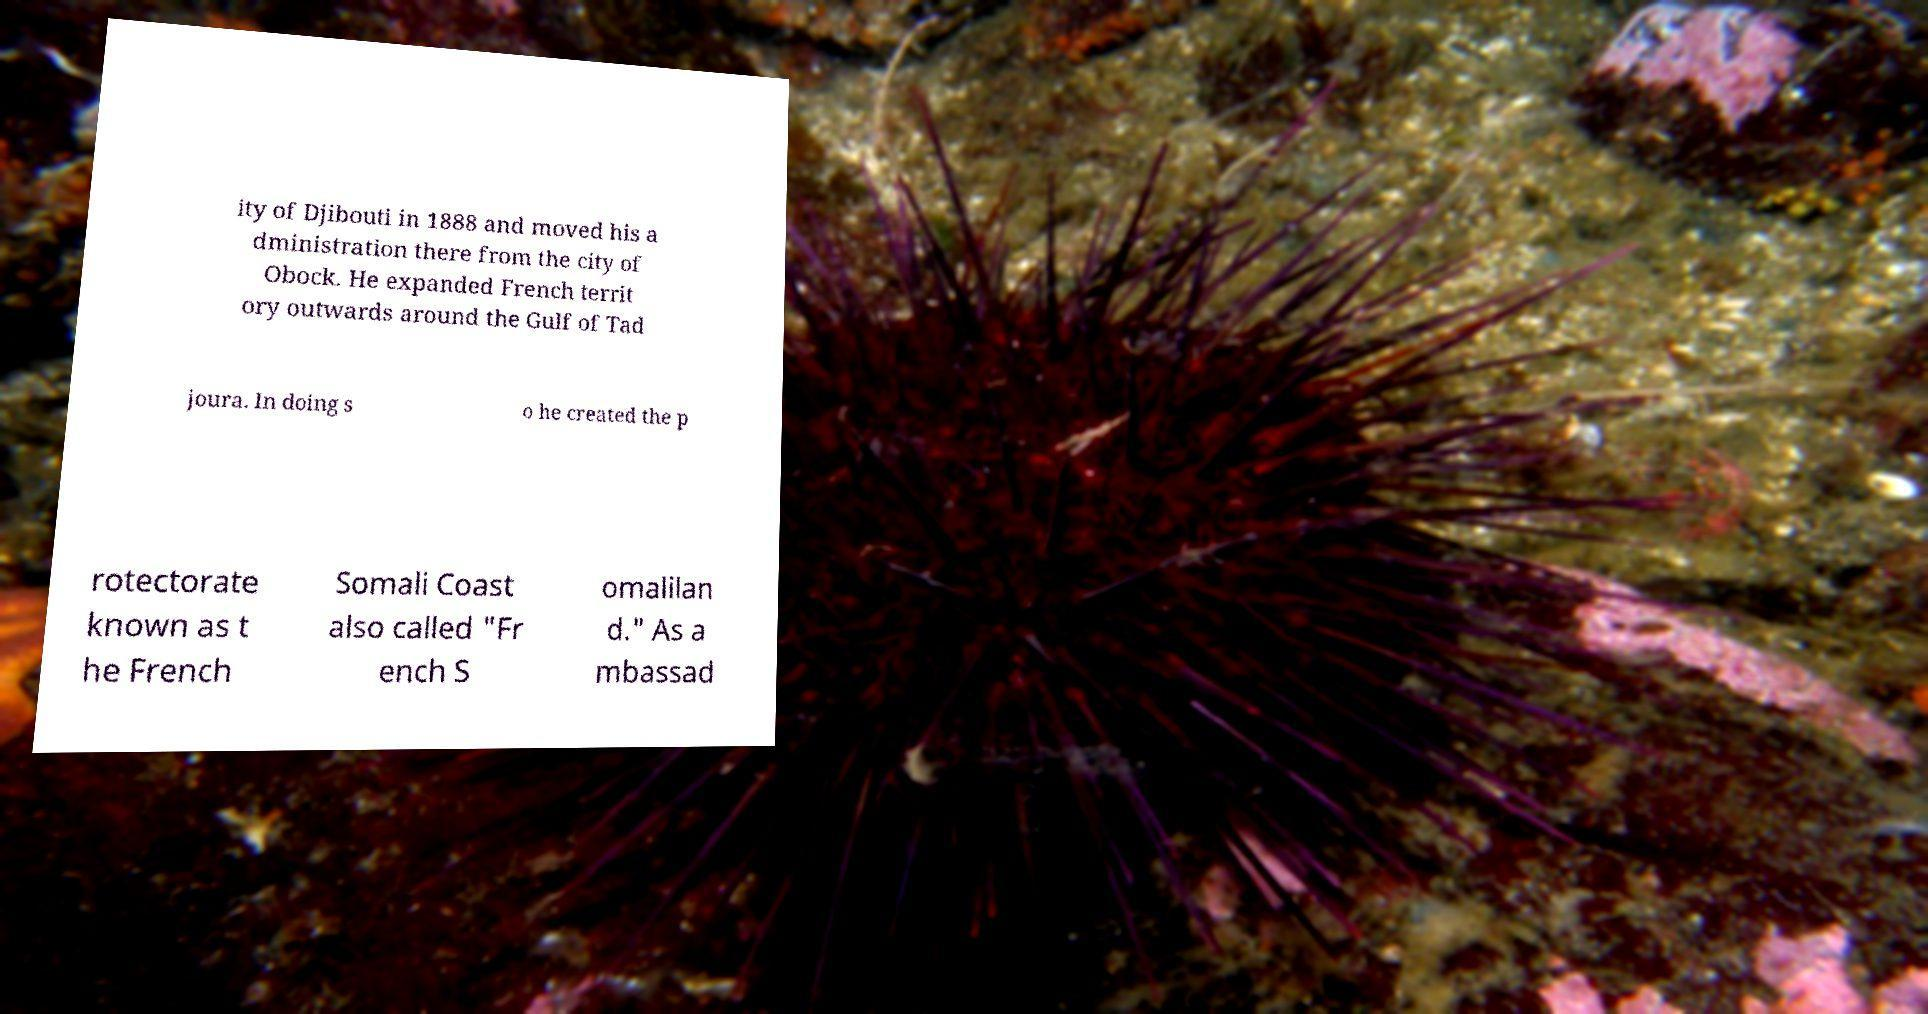Could you assist in decoding the text presented in this image and type it out clearly? ity of Djibouti in 1888 and moved his a dministration there from the city of Obock. He expanded French territ ory outwards around the Gulf of Tad joura. In doing s o he created the p rotectorate known as t he French Somali Coast also called "Fr ench S omalilan d." As a mbassad 